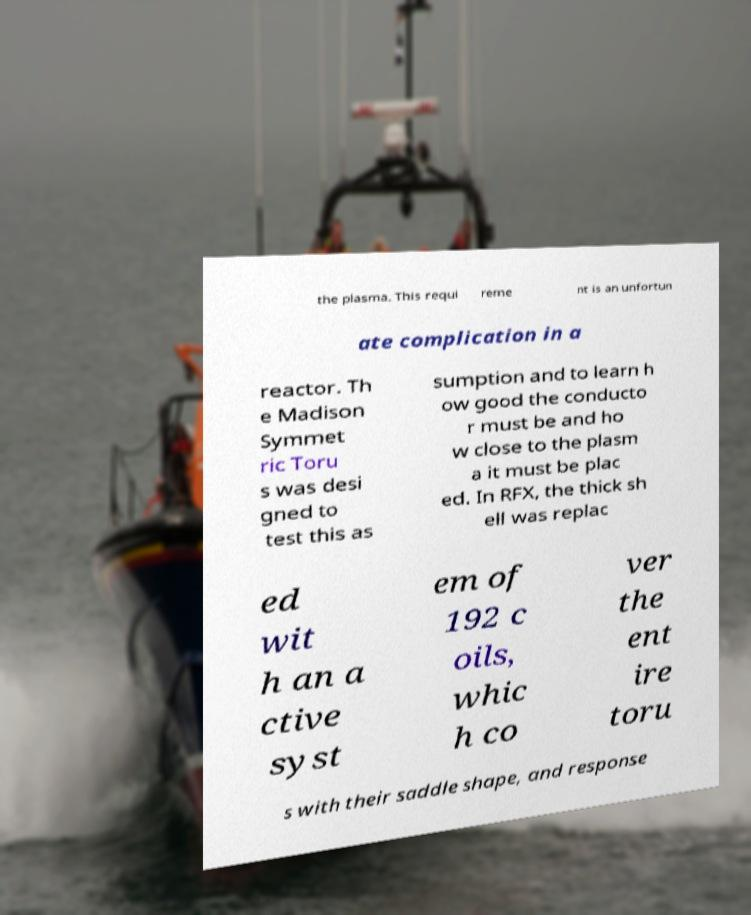There's text embedded in this image that I need extracted. Can you transcribe it verbatim? the plasma. This requi reme nt is an unfortun ate complication in a reactor. Th e Madison Symmet ric Toru s was desi gned to test this as sumption and to learn h ow good the conducto r must be and ho w close to the plasm a it must be plac ed. In RFX, the thick sh ell was replac ed wit h an a ctive syst em of 192 c oils, whic h co ver the ent ire toru s with their saddle shape, and response 